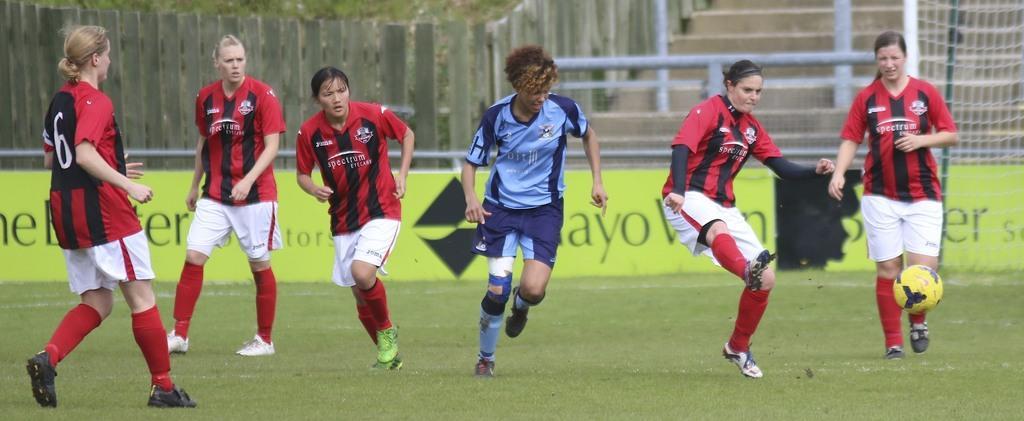Can you describe this image briefly? In the image we can see there are many people wearing clothes, socks and shoes, they are playing. This is a ball, grass, poster, net, stairs and a wooden fence. 